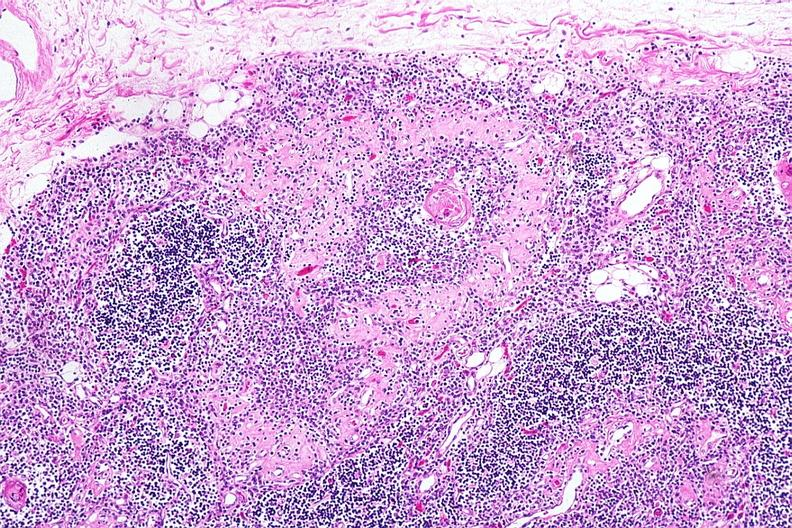what corpuscle with fibrosis in periphery of surrounding lymphoid follicle lesion?
Answer the question using a single word or phrase. Hassalls 